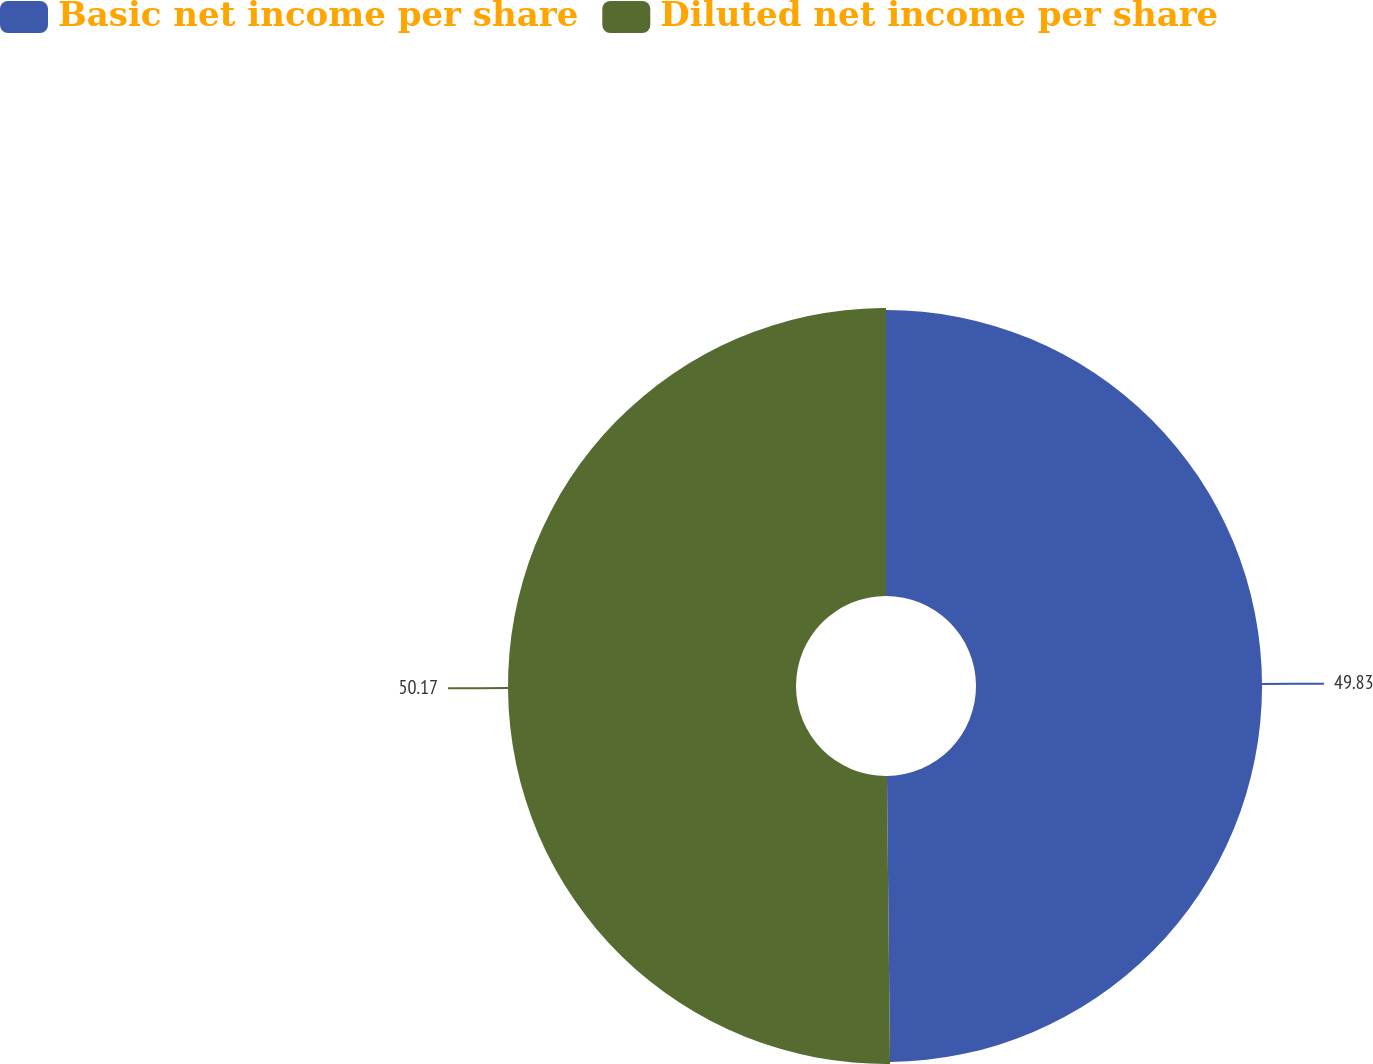Convert chart to OTSL. <chart><loc_0><loc_0><loc_500><loc_500><pie_chart><fcel>Basic net income per share<fcel>Diluted net income per share<nl><fcel>49.83%<fcel>50.17%<nl></chart> 